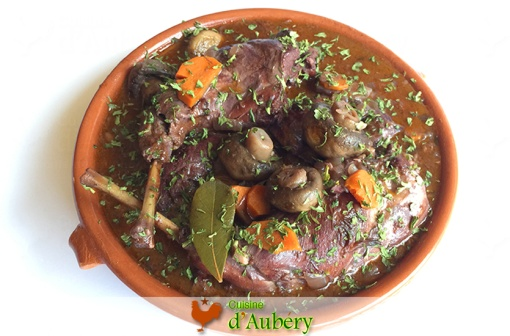Describe a long, realistic scenario for this dish. In a cozy bistro nestled in the charming streets of Burgundy, patrons gather for the evening meal. The air is filled with laughter, chatter, and the tantalizing scent of **Coq au Vin** simmering in the kitchen. The head chef, an elderly man with decades of culinary wisdom, carefully ladles the rich, wine-infused sauce over perfectly cooked chicken, mushrooms, and carrots, ensuring each plate is nothing short of perfection. As the waitstaff delivers the dishes to expectant diners, the room quiets momentarily, giving way to the orchestra of clinking cutlery and delighted hums of satisfaction. Conversations begin to bubble anew, punctuated by hearty praises and the occasional ‘Zut alors, c’est magnifique!’ The scene paints a picture of warmth, community, and the timeless joy of sharing a meal that transcends the ordinary, making it a memorable experience for everyone present. 